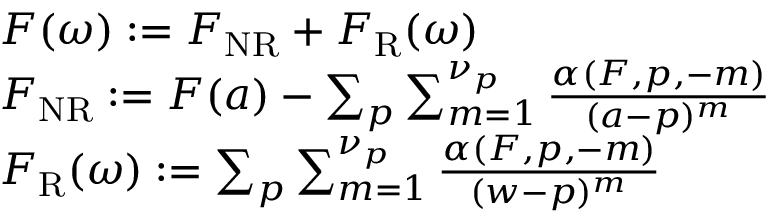<formula> <loc_0><loc_0><loc_500><loc_500>\begin{array} { r } { \begin{array} { r l } & { F ( \omega ) \colon = F _ { N R } + F _ { R } ( \omega ) } \\ & { F _ { N R } \colon = F ( a ) - \sum _ { p } \sum _ { m = 1 } ^ { \nu _ { p } } \frac { \alpha ( F , p , - m ) } { ( a - p ) ^ { m } } } \\ & { F _ { R } ( \omega ) \colon = \sum _ { p } \sum _ { m = 1 } ^ { \nu _ { p } } \frac { \alpha ( F , p , - m ) } { ( w - p ) ^ { m } } } \end{array} } \end{array}</formula> 